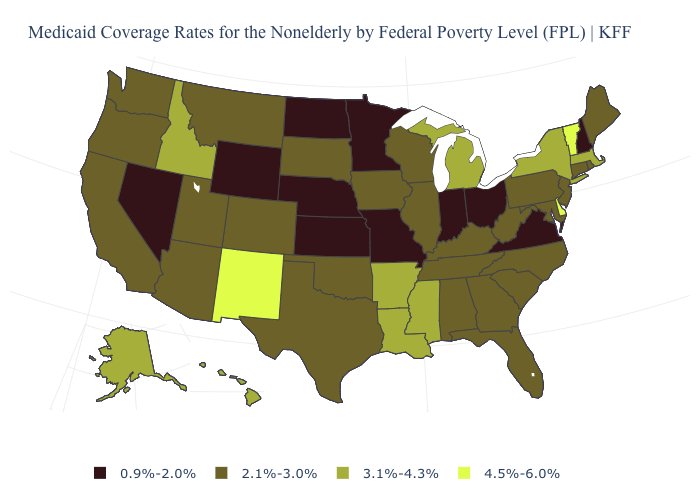What is the value of South Dakota?
Be succinct. 2.1%-3.0%. What is the value of Minnesota?
Short answer required. 0.9%-2.0%. How many symbols are there in the legend?
Quick response, please. 4. What is the lowest value in states that border Delaware?
Be succinct. 2.1%-3.0%. Does Texas have the same value as Washington?
Short answer required. Yes. Name the states that have a value in the range 3.1%-4.3%?
Write a very short answer. Alaska, Arkansas, Hawaii, Idaho, Louisiana, Massachusetts, Michigan, Mississippi, New York. What is the lowest value in the USA?
Write a very short answer. 0.9%-2.0%. What is the value of Missouri?
Give a very brief answer. 0.9%-2.0%. What is the value of Michigan?
Write a very short answer. 3.1%-4.3%. What is the highest value in the USA?
Short answer required. 4.5%-6.0%. Does Ohio have the lowest value in the USA?
Give a very brief answer. Yes. Does Maryland have the same value as New Jersey?
Answer briefly. Yes. What is the highest value in states that border Nevada?
Keep it brief. 3.1%-4.3%. Does the first symbol in the legend represent the smallest category?
Short answer required. Yes. What is the value of Maine?
Write a very short answer. 2.1%-3.0%. 